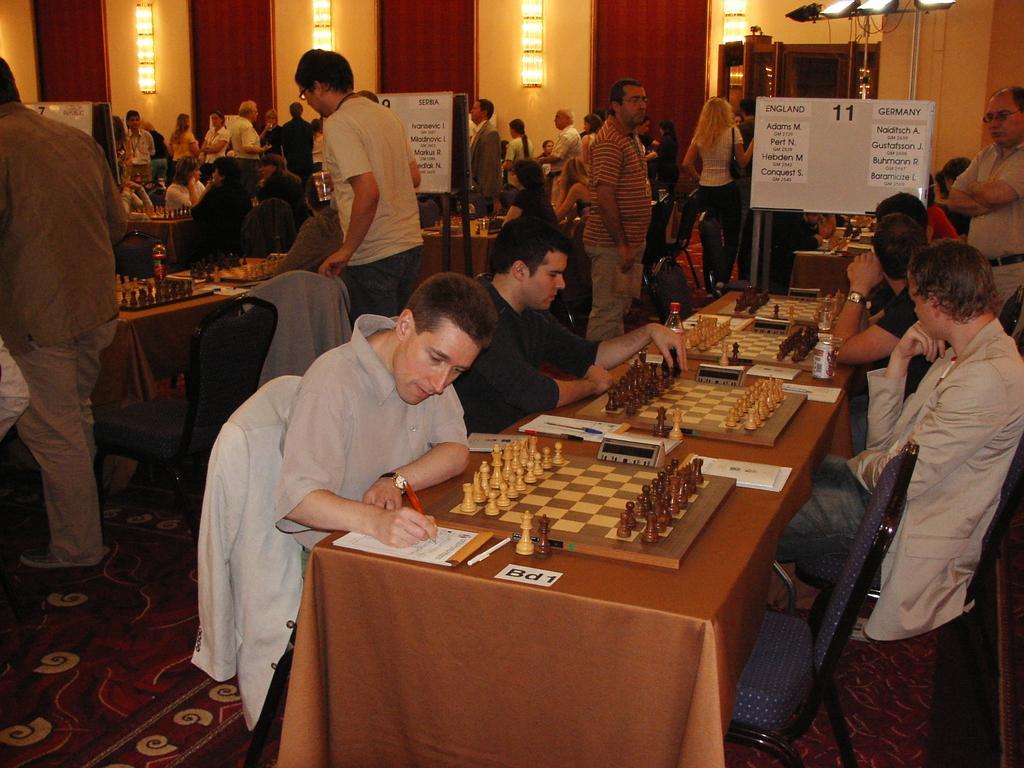Could you give a brief overview of what you see in this image? In this image I can see group of people siting in front of the table. And some people are standing. On the table there is a chess board and the pieces. There are also few papers on the table. One person is holding a pen and writing on that. In the back there is a board,lights and the door. 